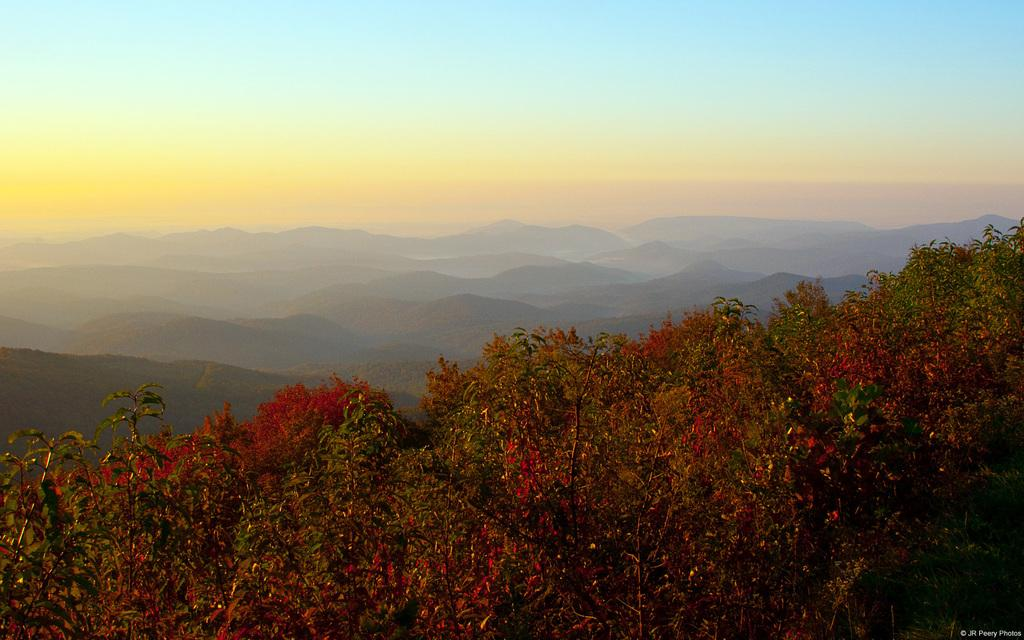What type of natural landscape is depicted in the image? The image features mountains. What other types of vegetation can be seen in the image? There are trees and plants in the image. Are there any specific features of the trees in the image? Yes, there are flowers on the trees in the image. What type of pickle is hanging from the trees in the image? There are no pickles present in the image; it features flowers on the trees. 